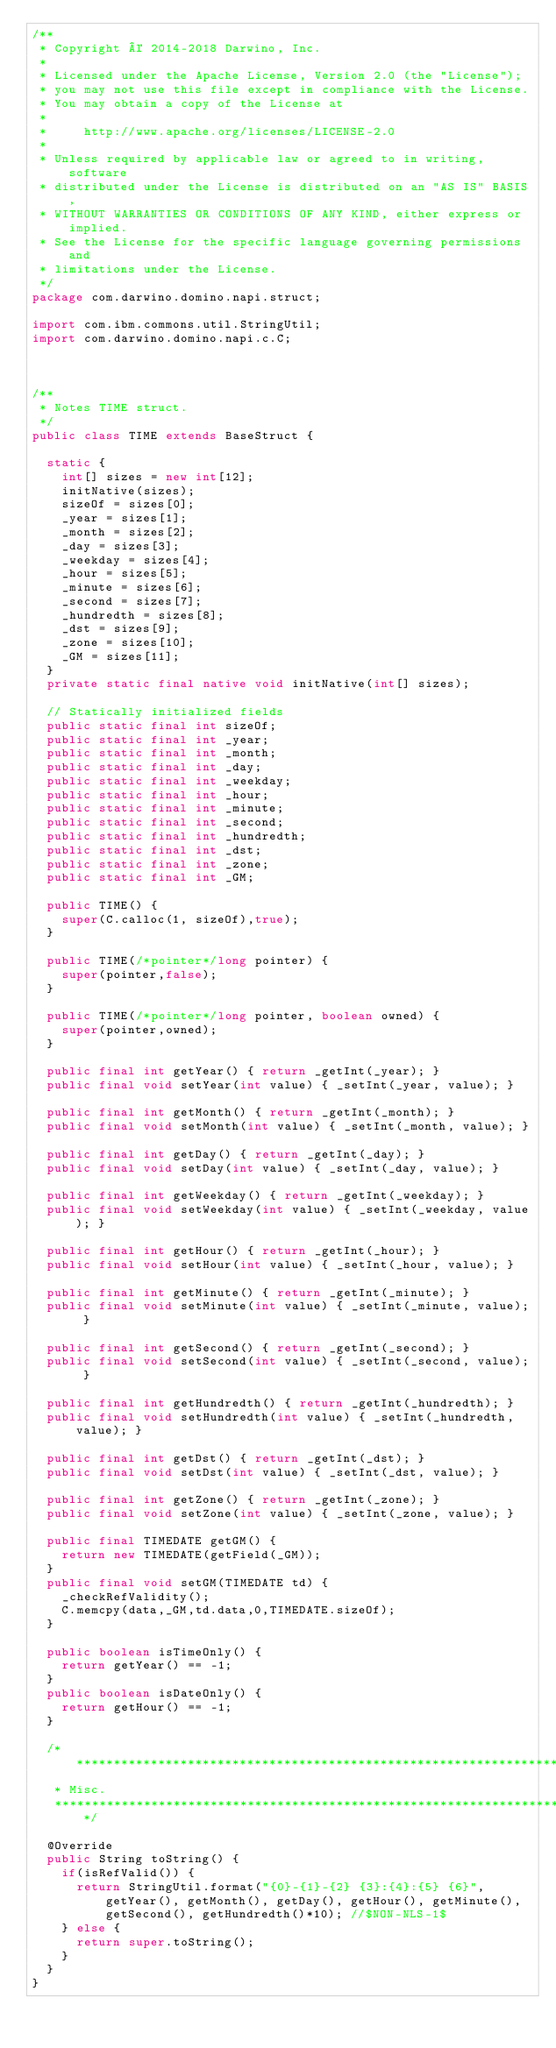<code> <loc_0><loc_0><loc_500><loc_500><_Java_>/**
 * Copyright © 2014-2018 Darwino, Inc.
 *
 * Licensed under the Apache License, Version 2.0 (the "License");
 * you may not use this file except in compliance with the License.
 * You may obtain a copy of the License at
 *
 *     http://www.apache.org/licenses/LICENSE-2.0
 *
 * Unless required by applicable law or agreed to in writing, software
 * distributed under the License is distributed on an "AS IS" BASIS,
 * WITHOUT WARRANTIES OR CONDITIONS OF ANY KIND, either express or implied.
 * See the License for the specific language governing permissions and
 * limitations under the License.
 */
package com.darwino.domino.napi.struct;

import com.ibm.commons.util.StringUtil;
import com.darwino.domino.napi.c.C;



/**
 * Notes TIME struct.
 */
public class TIME extends BaseStruct {

	static {
		int[] sizes = new int[12];
		initNative(sizes);
		sizeOf = sizes[0];
		_year = sizes[1];
		_month = sizes[2];
		_day = sizes[3];
		_weekday = sizes[4];
		_hour = sizes[5];
		_minute = sizes[6];
		_second = sizes[7];
		_hundredth = sizes[8];
		_dst = sizes[9];
		_zone = sizes[10];
		_GM = sizes[11];
	}
	private static final native void initNative(int[] sizes);
	
	// Statically initialized fields
	public static final int sizeOf;
	public static final int _year;
	public static final int _month;
	public static final int _day;
	public static final int _weekday;
	public static final int _hour;
	public static final int _minute;
	public static final int _second;
	public static final int _hundredth;
	public static final int _dst;
	public static final int _zone;
	public static final int _GM;
			
	public TIME() {
		super(C.calloc(1, sizeOf),true);
	}

	public TIME(/*pointer*/long pointer) {
		super(pointer,false);
	}

	public TIME(/*pointer*/long pointer, boolean owned) {
		super(pointer,owned);
	}
	
	public final int getYear() { return _getInt(_year); }
	public final void setYear(int value) { _setInt(_year, value); }
	
	public final int getMonth() { return _getInt(_month); }
	public final void setMonth(int value) { _setInt(_month, value); }
	
	public final int getDay() { return _getInt(_day); }
	public final void setDay(int value) { _setInt(_day, value); }
	
	public final int getWeekday() { return _getInt(_weekday); }
	public final void setWeekday(int value) { _setInt(_weekday, value); }
	
	public final int getHour() { return _getInt(_hour); }
	public final void setHour(int value) { _setInt(_hour, value); }
	
	public final int getMinute() { return _getInt(_minute); }
	public final void setMinute(int value) { _setInt(_minute, value); }
	
	public final int getSecond() { return _getInt(_second); }
	public final void setSecond(int value) { _setInt(_second, value); }
	
	public final int getHundredth() { return _getInt(_hundredth); }
	public final void setHundredth(int value) { _setInt(_hundredth, value); }

	public final int getDst() { return _getInt(_dst); }
	public final void setDst(int value) { _setInt(_dst, value); }

	public final int getZone() { return _getInt(_zone); }
	public final void setZone(int value) { _setInt(_zone, value); }
		
	public final TIMEDATE getGM() {
		return new TIMEDATE(getField(_GM)); 
	}
	public final void setGM(TIMEDATE td) {
		_checkRefValidity();
		C.memcpy(data,_GM,td.data,0,TIMEDATE.sizeOf);
	}
	
	public boolean isTimeOnly() {
		return getYear() == -1;
	}
	public boolean isDateOnly() {
		return getHour() == -1;
	}
	
	/* ******************************************************************************
	 * Misc.
	 ********************************************************************************/

	@Override
	public String toString() {
		if(isRefValid()) {
			return StringUtil.format("{0}-{1}-{2} {3}:{4}:{5} {6}", getYear(), getMonth(), getDay(), getHour(), getMinute(), getSecond(), getHundredth()*10); //$NON-NLS-1$
		} else {
			return super.toString();
		}
	}
}
</code> 